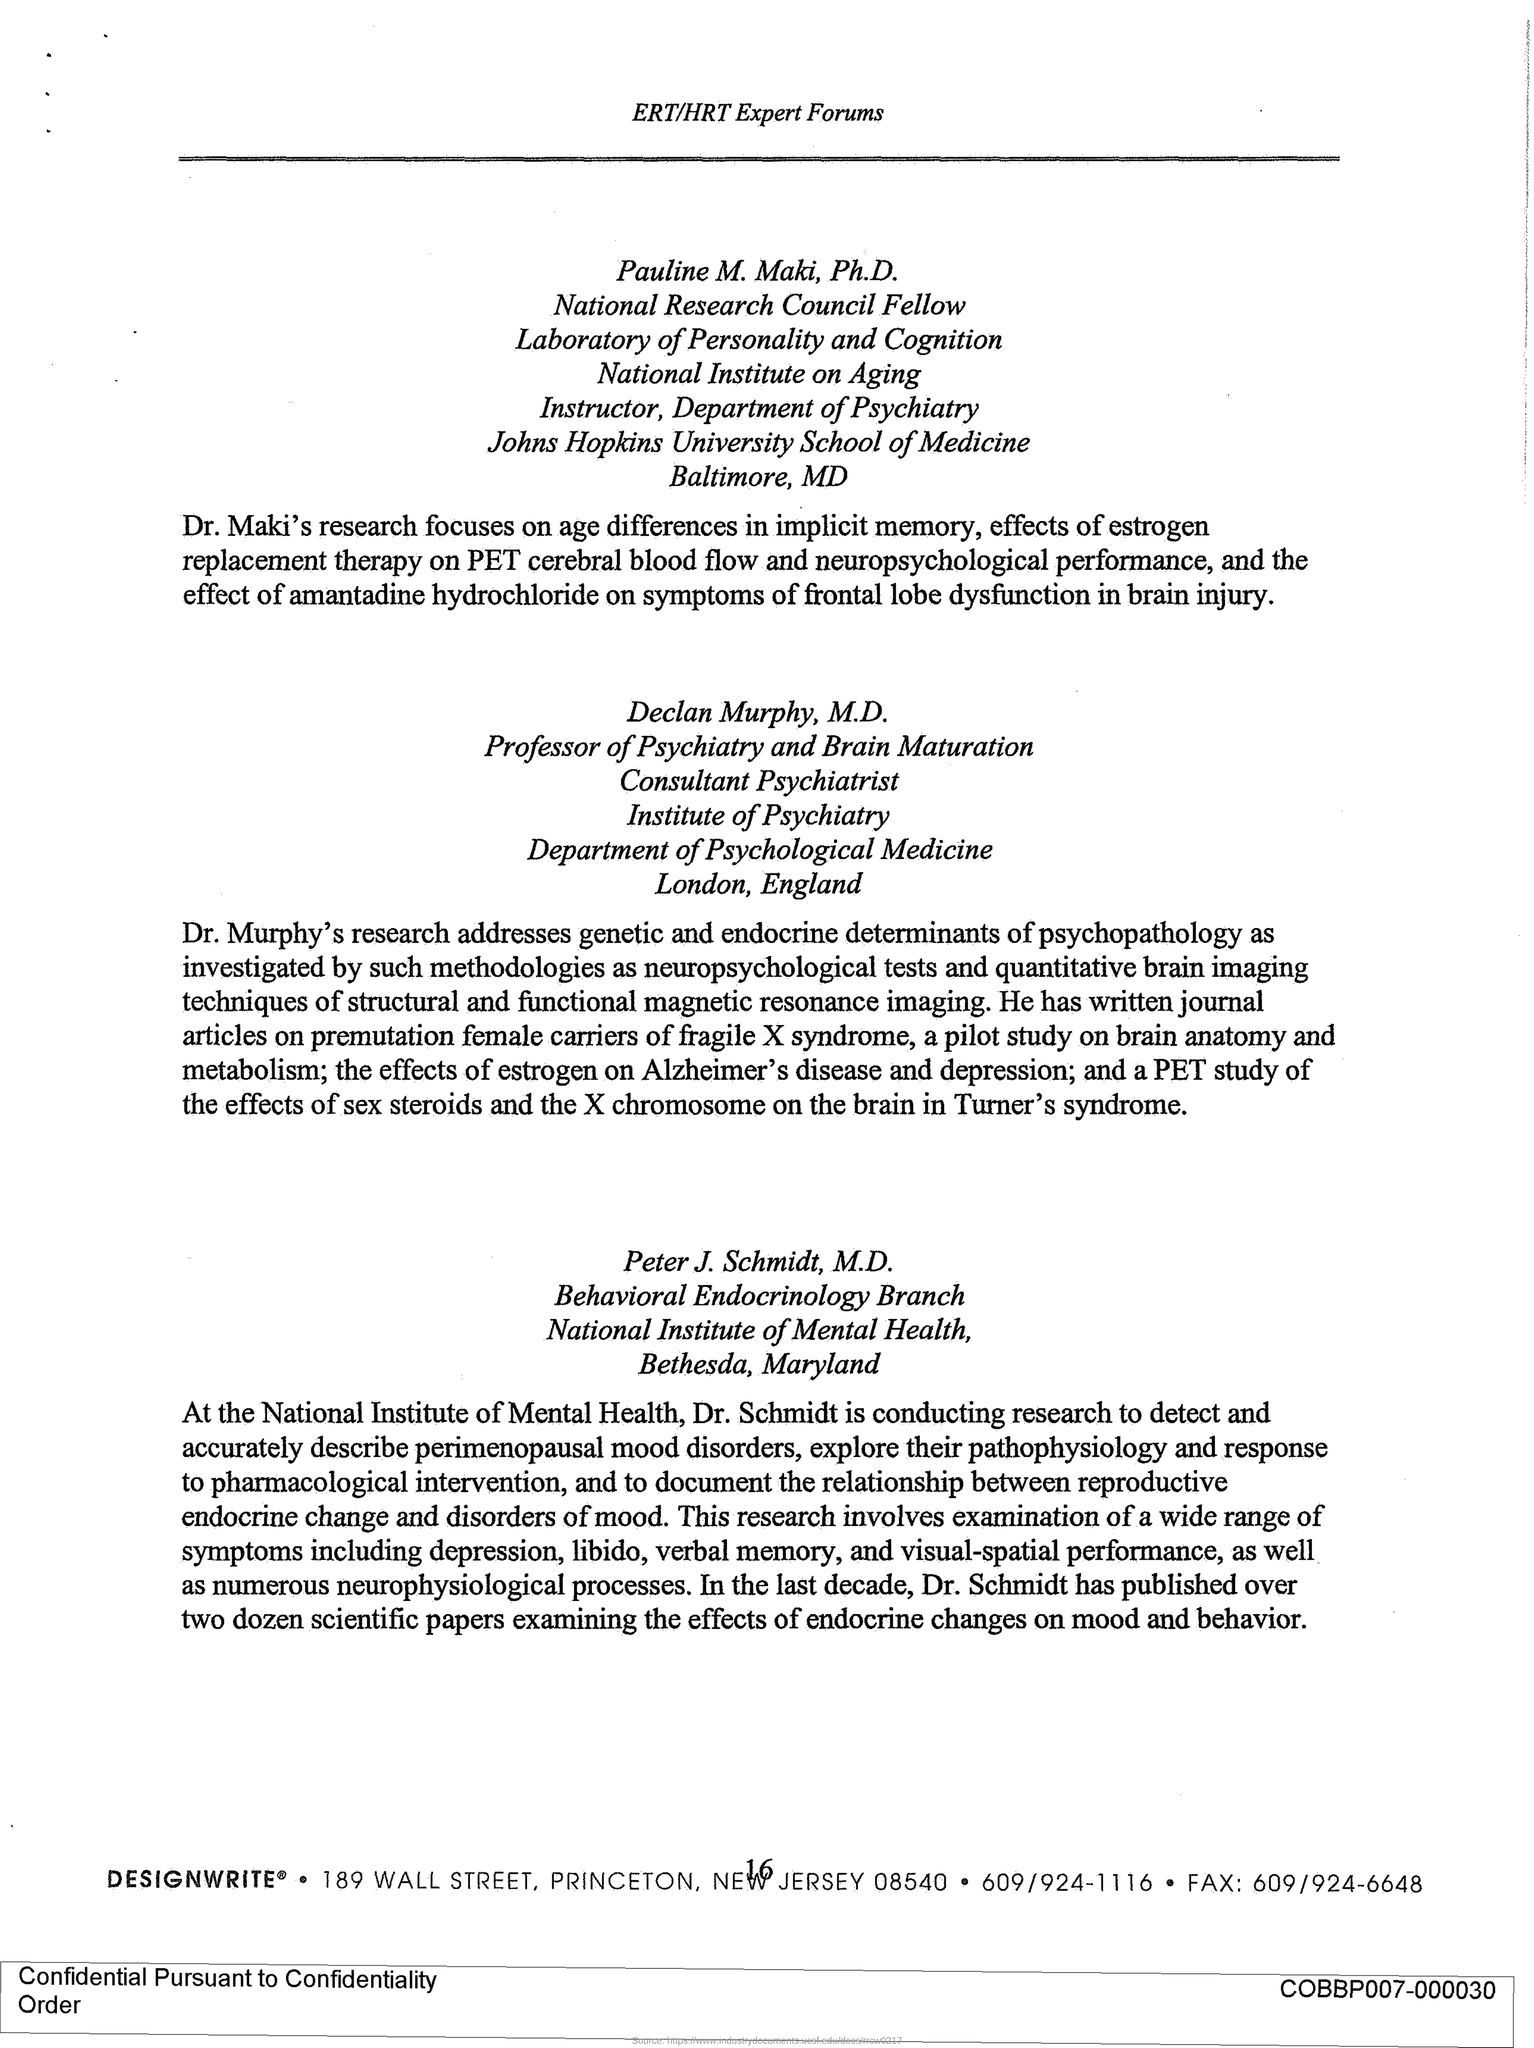Highlight a few significant elements in this photo. Declan Murphy, M.D., is the Professor of Psychiatry and Brain Maturation. Pauline is a National Research Council Fellow. Peter J. Schmidt, M.D. is part of the Behavioral Endocrinology Branch. 